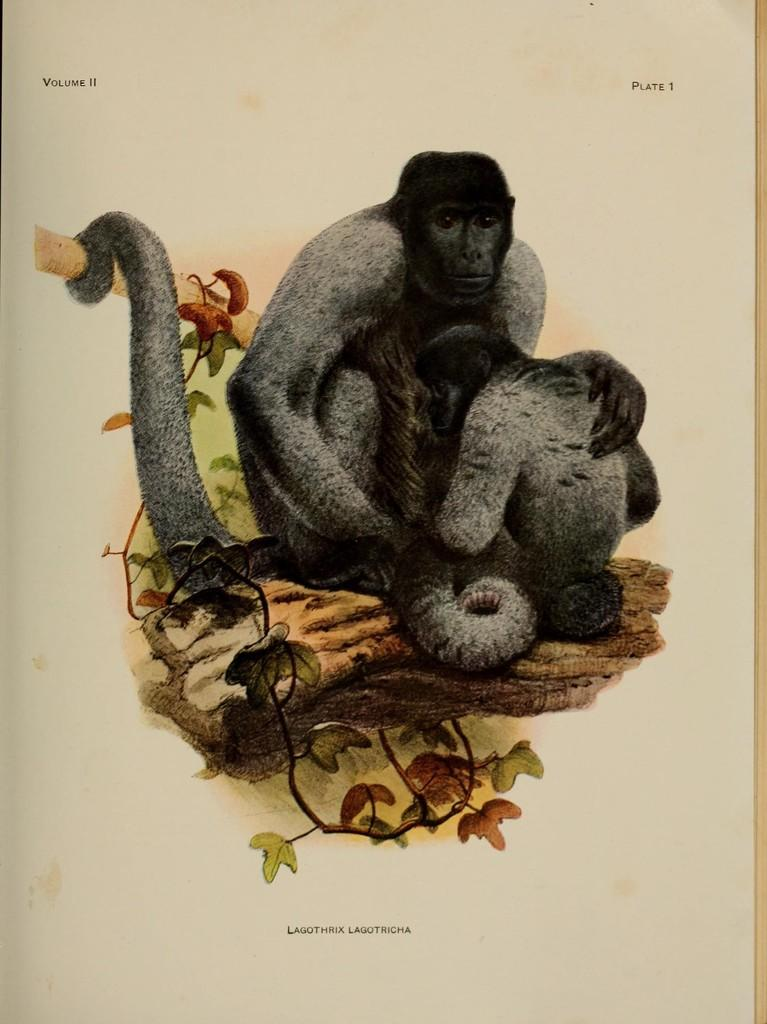What type of drawing is shown in the image? The image is a sketch. What animals can be seen in the sketch? There are monkeys on a branch in the sketch. What type of vegetation is depicted in the sketch? There are leaves depicted in the sketch. Is there any text present in the sketch? Yes, there is text present in the sketch. Where is the oven located in the sketch? There is no oven present in the sketch. What type of roof is depicted in the sketch? There is no roof depicted in the sketch. 